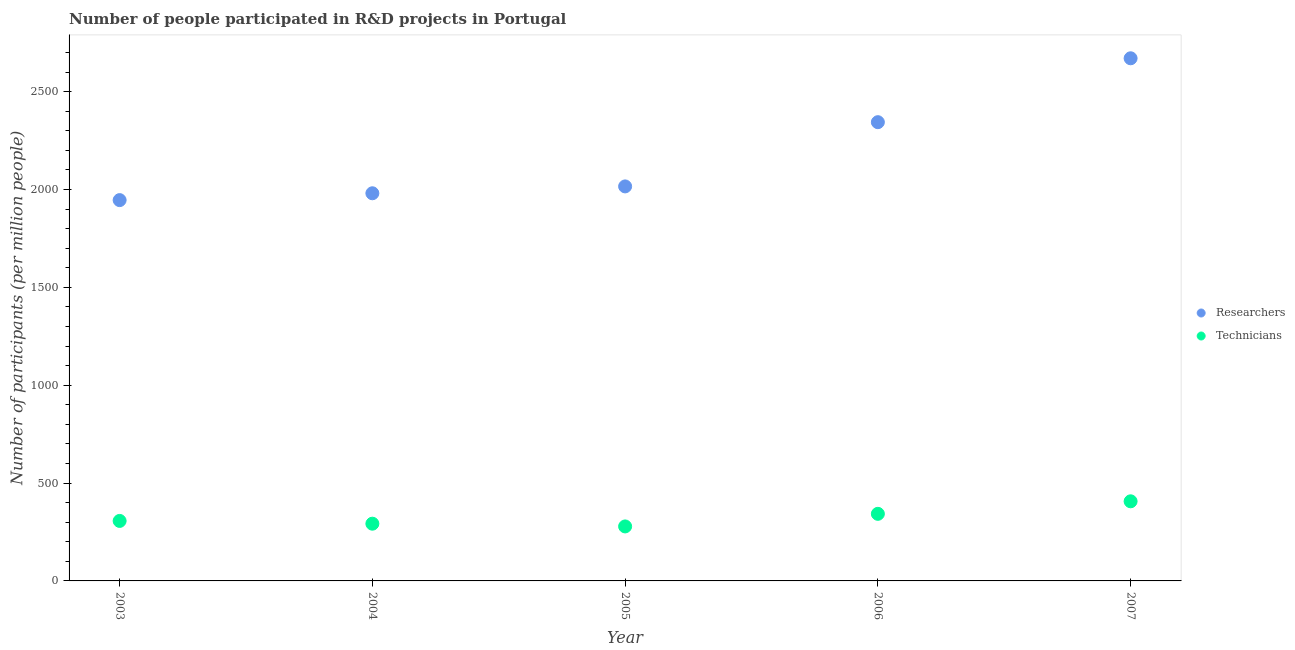Is the number of dotlines equal to the number of legend labels?
Your answer should be compact. Yes. What is the number of researchers in 2006?
Your answer should be very brief. 2344.02. Across all years, what is the maximum number of technicians?
Offer a terse response. 406.8. Across all years, what is the minimum number of technicians?
Provide a succinct answer. 278.47. In which year was the number of technicians maximum?
Provide a succinct answer. 2007. What is the total number of researchers in the graph?
Your answer should be compact. 1.10e+04. What is the difference between the number of researchers in 2004 and that in 2005?
Provide a succinct answer. -35.07. What is the difference between the number of technicians in 2003 and the number of researchers in 2007?
Keep it short and to the point. -2363.95. What is the average number of researchers per year?
Keep it short and to the point. 2191.4. In the year 2007, what is the difference between the number of researchers and number of technicians?
Your response must be concise. 2263.72. In how many years, is the number of researchers greater than 200?
Make the answer very short. 5. What is the ratio of the number of technicians in 2003 to that in 2004?
Keep it short and to the point. 1.05. Is the difference between the number of researchers in 2006 and 2007 greater than the difference between the number of technicians in 2006 and 2007?
Ensure brevity in your answer.  No. What is the difference between the highest and the second highest number of researchers?
Give a very brief answer. 326.5. What is the difference between the highest and the lowest number of researchers?
Offer a very short reply. 724.71. In how many years, is the number of technicians greater than the average number of technicians taken over all years?
Your answer should be compact. 2. Is the sum of the number of technicians in 2005 and 2006 greater than the maximum number of researchers across all years?
Give a very brief answer. No. Does the graph contain grids?
Provide a short and direct response. No. How many legend labels are there?
Keep it short and to the point. 2. How are the legend labels stacked?
Provide a succinct answer. Vertical. What is the title of the graph?
Offer a terse response. Number of people participated in R&D projects in Portugal. What is the label or title of the X-axis?
Offer a terse response. Year. What is the label or title of the Y-axis?
Your answer should be compact. Number of participants (per million people). What is the Number of participants (per million people) of Researchers in 2003?
Your answer should be very brief. 1945.82. What is the Number of participants (per million people) of Technicians in 2003?
Your answer should be compact. 306.57. What is the Number of participants (per million people) of Researchers in 2004?
Provide a short and direct response. 1980.77. What is the Number of participants (per million people) of Technicians in 2004?
Your answer should be very brief. 292.44. What is the Number of participants (per million people) of Researchers in 2005?
Provide a succinct answer. 2015.85. What is the Number of participants (per million people) of Technicians in 2005?
Offer a very short reply. 278.47. What is the Number of participants (per million people) in Researchers in 2006?
Your response must be concise. 2344.02. What is the Number of participants (per million people) of Technicians in 2006?
Ensure brevity in your answer.  342.81. What is the Number of participants (per million people) in Researchers in 2007?
Make the answer very short. 2670.52. What is the Number of participants (per million people) of Technicians in 2007?
Make the answer very short. 406.8. Across all years, what is the maximum Number of participants (per million people) in Researchers?
Offer a very short reply. 2670.52. Across all years, what is the maximum Number of participants (per million people) of Technicians?
Your answer should be very brief. 406.8. Across all years, what is the minimum Number of participants (per million people) in Researchers?
Your response must be concise. 1945.82. Across all years, what is the minimum Number of participants (per million people) in Technicians?
Your answer should be compact. 278.47. What is the total Number of participants (per million people) of Researchers in the graph?
Your answer should be compact. 1.10e+04. What is the total Number of participants (per million people) in Technicians in the graph?
Your answer should be compact. 1627.1. What is the difference between the Number of participants (per million people) in Researchers in 2003 and that in 2004?
Offer a terse response. -34.96. What is the difference between the Number of participants (per million people) in Technicians in 2003 and that in 2004?
Your response must be concise. 14.13. What is the difference between the Number of participants (per million people) in Researchers in 2003 and that in 2005?
Your answer should be compact. -70.03. What is the difference between the Number of participants (per million people) in Technicians in 2003 and that in 2005?
Keep it short and to the point. 28.1. What is the difference between the Number of participants (per million people) of Researchers in 2003 and that in 2006?
Your answer should be very brief. -398.21. What is the difference between the Number of participants (per million people) of Technicians in 2003 and that in 2006?
Provide a short and direct response. -36.24. What is the difference between the Number of participants (per million people) of Researchers in 2003 and that in 2007?
Offer a very short reply. -724.71. What is the difference between the Number of participants (per million people) of Technicians in 2003 and that in 2007?
Your response must be concise. -100.23. What is the difference between the Number of participants (per million people) of Researchers in 2004 and that in 2005?
Keep it short and to the point. -35.07. What is the difference between the Number of participants (per million people) in Technicians in 2004 and that in 2005?
Your response must be concise. 13.97. What is the difference between the Number of participants (per million people) in Researchers in 2004 and that in 2006?
Ensure brevity in your answer.  -363.25. What is the difference between the Number of participants (per million people) of Technicians in 2004 and that in 2006?
Provide a short and direct response. -50.37. What is the difference between the Number of participants (per million people) of Researchers in 2004 and that in 2007?
Offer a very short reply. -689.75. What is the difference between the Number of participants (per million people) of Technicians in 2004 and that in 2007?
Offer a terse response. -114.36. What is the difference between the Number of participants (per million people) of Researchers in 2005 and that in 2006?
Offer a terse response. -328.18. What is the difference between the Number of participants (per million people) of Technicians in 2005 and that in 2006?
Offer a terse response. -64.34. What is the difference between the Number of participants (per million people) of Researchers in 2005 and that in 2007?
Provide a succinct answer. -654.68. What is the difference between the Number of participants (per million people) of Technicians in 2005 and that in 2007?
Provide a short and direct response. -128.33. What is the difference between the Number of participants (per million people) of Researchers in 2006 and that in 2007?
Provide a succinct answer. -326.5. What is the difference between the Number of participants (per million people) of Technicians in 2006 and that in 2007?
Make the answer very short. -63.99. What is the difference between the Number of participants (per million people) in Researchers in 2003 and the Number of participants (per million people) in Technicians in 2004?
Your response must be concise. 1653.37. What is the difference between the Number of participants (per million people) of Researchers in 2003 and the Number of participants (per million people) of Technicians in 2005?
Give a very brief answer. 1667.35. What is the difference between the Number of participants (per million people) in Researchers in 2003 and the Number of participants (per million people) in Technicians in 2006?
Offer a very short reply. 1603. What is the difference between the Number of participants (per million people) in Researchers in 2003 and the Number of participants (per million people) in Technicians in 2007?
Offer a terse response. 1539.01. What is the difference between the Number of participants (per million people) of Researchers in 2004 and the Number of participants (per million people) of Technicians in 2005?
Provide a short and direct response. 1702.3. What is the difference between the Number of participants (per million people) of Researchers in 2004 and the Number of participants (per million people) of Technicians in 2006?
Your response must be concise. 1637.96. What is the difference between the Number of participants (per million people) in Researchers in 2004 and the Number of participants (per million people) in Technicians in 2007?
Provide a succinct answer. 1573.97. What is the difference between the Number of participants (per million people) of Researchers in 2005 and the Number of participants (per million people) of Technicians in 2006?
Your answer should be very brief. 1673.03. What is the difference between the Number of participants (per million people) in Researchers in 2005 and the Number of participants (per million people) in Technicians in 2007?
Your answer should be very brief. 1609.05. What is the difference between the Number of participants (per million people) in Researchers in 2006 and the Number of participants (per million people) in Technicians in 2007?
Offer a terse response. 1937.22. What is the average Number of participants (per million people) of Researchers per year?
Your response must be concise. 2191.4. What is the average Number of participants (per million people) of Technicians per year?
Ensure brevity in your answer.  325.42. In the year 2003, what is the difference between the Number of participants (per million people) of Researchers and Number of participants (per million people) of Technicians?
Offer a terse response. 1639.24. In the year 2004, what is the difference between the Number of participants (per million people) of Researchers and Number of participants (per million people) of Technicians?
Provide a succinct answer. 1688.33. In the year 2005, what is the difference between the Number of participants (per million people) in Researchers and Number of participants (per million people) in Technicians?
Provide a short and direct response. 1737.38. In the year 2006, what is the difference between the Number of participants (per million people) in Researchers and Number of participants (per million people) in Technicians?
Your answer should be compact. 2001.21. In the year 2007, what is the difference between the Number of participants (per million people) in Researchers and Number of participants (per million people) in Technicians?
Your response must be concise. 2263.72. What is the ratio of the Number of participants (per million people) in Researchers in 2003 to that in 2004?
Give a very brief answer. 0.98. What is the ratio of the Number of participants (per million people) of Technicians in 2003 to that in 2004?
Your answer should be compact. 1.05. What is the ratio of the Number of participants (per million people) in Researchers in 2003 to that in 2005?
Your answer should be very brief. 0.97. What is the ratio of the Number of participants (per million people) in Technicians in 2003 to that in 2005?
Offer a terse response. 1.1. What is the ratio of the Number of participants (per million people) of Researchers in 2003 to that in 2006?
Ensure brevity in your answer.  0.83. What is the ratio of the Number of participants (per million people) of Technicians in 2003 to that in 2006?
Keep it short and to the point. 0.89. What is the ratio of the Number of participants (per million people) of Researchers in 2003 to that in 2007?
Your answer should be very brief. 0.73. What is the ratio of the Number of participants (per million people) in Technicians in 2003 to that in 2007?
Your response must be concise. 0.75. What is the ratio of the Number of participants (per million people) of Researchers in 2004 to that in 2005?
Give a very brief answer. 0.98. What is the ratio of the Number of participants (per million people) in Technicians in 2004 to that in 2005?
Your answer should be compact. 1.05. What is the ratio of the Number of participants (per million people) in Researchers in 2004 to that in 2006?
Offer a very short reply. 0.84. What is the ratio of the Number of participants (per million people) of Technicians in 2004 to that in 2006?
Offer a terse response. 0.85. What is the ratio of the Number of participants (per million people) in Researchers in 2004 to that in 2007?
Keep it short and to the point. 0.74. What is the ratio of the Number of participants (per million people) in Technicians in 2004 to that in 2007?
Your response must be concise. 0.72. What is the ratio of the Number of participants (per million people) in Researchers in 2005 to that in 2006?
Your answer should be compact. 0.86. What is the ratio of the Number of participants (per million people) in Technicians in 2005 to that in 2006?
Your response must be concise. 0.81. What is the ratio of the Number of participants (per million people) in Researchers in 2005 to that in 2007?
Your answer should be compact. 0.75. What is the ratio of the Number of participants (per million people) in Technicians in 2005 to that in 2007?
Offer a very short reply. 0.68. What is the ratio of the Number of participants (per million people) in Researchers in 2006 to that in 2007?
Your answer should be compact. 0.88. What is the ratio of the Number of participants (per million people) of Technicians in 2006 to that in 2007?
Offer a very short reply. 0.84. What is the difference between the highest and the second highest Number of participants (per million people) in Researchers?
Provide a short and direct response. 326.5. What is the difference between the highest and the second highest Number of participants (per million people) in Technicians?
Your response must be concise. 63.99. What is the difference between the highest and the lowest Number of participants (per million people) of Researchers?
Ensure brevity in your answer.  724.71. What is the difference between the highest and the lowest Number of participants (per million people) in Technicians?
Make the answer very short. 128.33. 